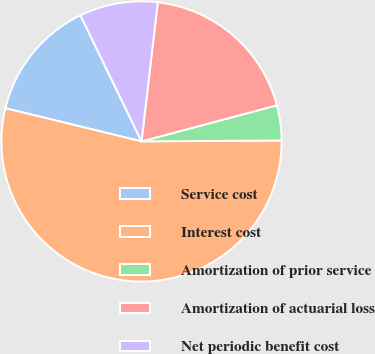Convert chart to OTSL. <chart><loc_0><loc_0><loc_500><loc_500><pie_chart><fcel>Service cost<fcel>Interest cost<fcel>Amortization of prior service<fcel>Amortization of actuarial loss<fcel>Net periodic benefit cost<nl><fcel>14.02%<fcel>53.91%<fcel>4.04%<fcel>19.0%<fcel>9.03%<nl></chart> 